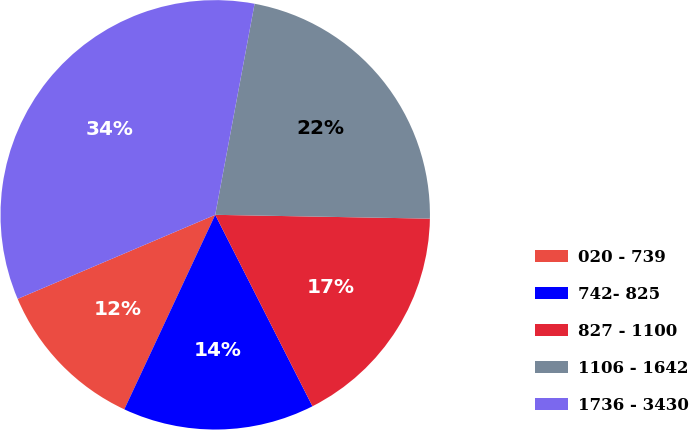Convert chart. <chart><loc_0><loc_0><loc_500><loc_500><pie_chart><fcel>020 - 739<fcel>742- 825<fcel>827 - 1100<fcel>1106 - 1642<fcel>1736 - 3430<nl><fcel>11.64%<fcel>14.44%<fcel>17.24%<fcel>22.35%<fcel>34.34%<nl></chart> 